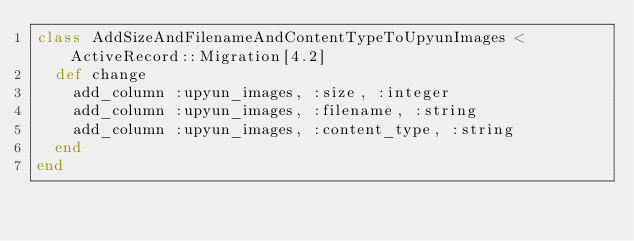<code> <loc_0><loc_0><loc_500><loc_500><_Ruby_>class AddSizeAndFilenameAndContentTypeToUpyunImages < ActiveRecord::Migration[4.2]
  def change
    add_column :upyun_images, :size, :integer
    add_column :upyun_images, :filename, :string
    add_column :upyun_images, :content_type, :string
  end
end
</code> 